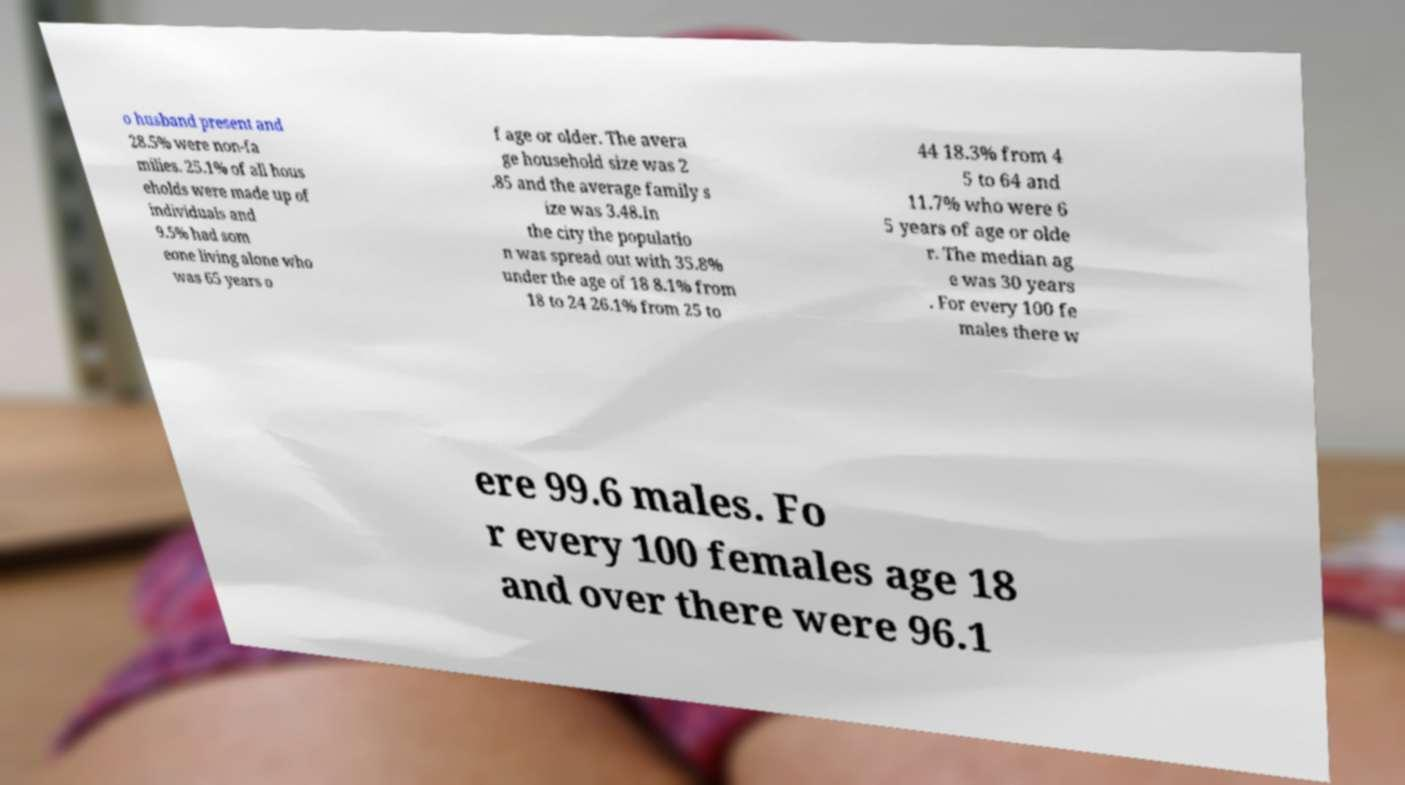Could you extract and type out the text from this image? o husband present and 28.5% were non-fa milies. 25.1% of all hous eholds were made up of individuals and 9.5% had som eone living alone who was 65 years o f age or older. The avera ge household size was 2 .85 and the average family s ize was 3.48.In the city the populatio n was spread out with 35.8% under the age of 18 8.1% from 18 to 24 26.1% from 25 to 44 18.3% from 4 5 to 64 and 11.7% who were 6 5 years of age or olde r. The median ag e was 30 years . For every 100 fe males there w ere 99.6 males. Fo r every 100 females age 18 and over there were 96.1 